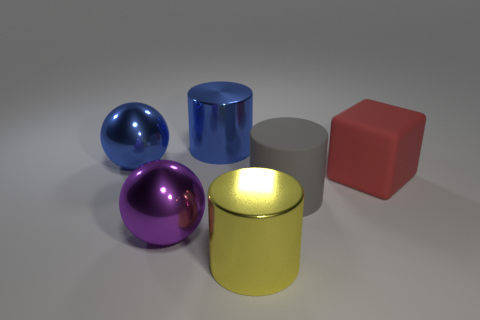Do the purple metallic thing and the shiny thing left of the purple object have the same shape? yes 